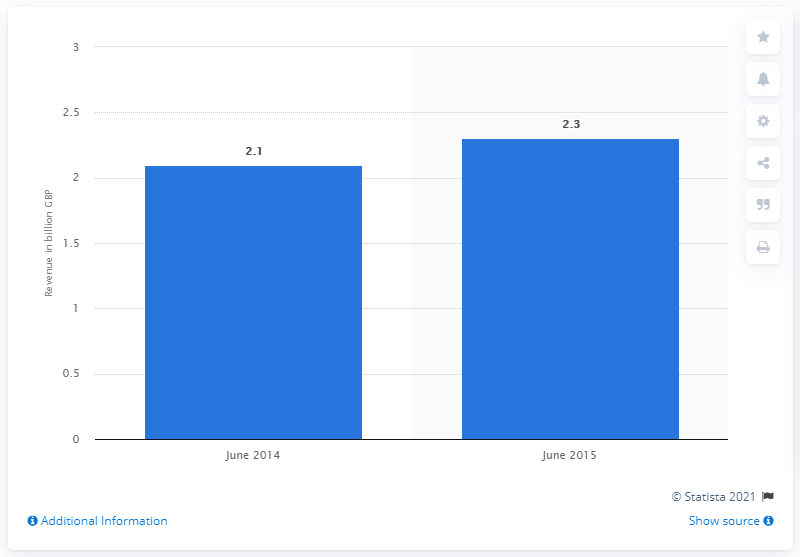Indicate a few pertinent items in this graphic. In the 12 months ending in June 2015, the value of pop-up retail was approximately $2.3 billion. In the year to June 2014, the value of pop-up retail was estimated to be 2.1 billion dollars. 